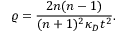Convert formula to latex. <formula><loc_0><loc_0><loc_500><loc_500>\varrho = \frac { 2 n ( n - 1 ) } { ( n + 1 ) ^ { 2 } \kappa _ { D } t ^ { 2 } } .</formula> 